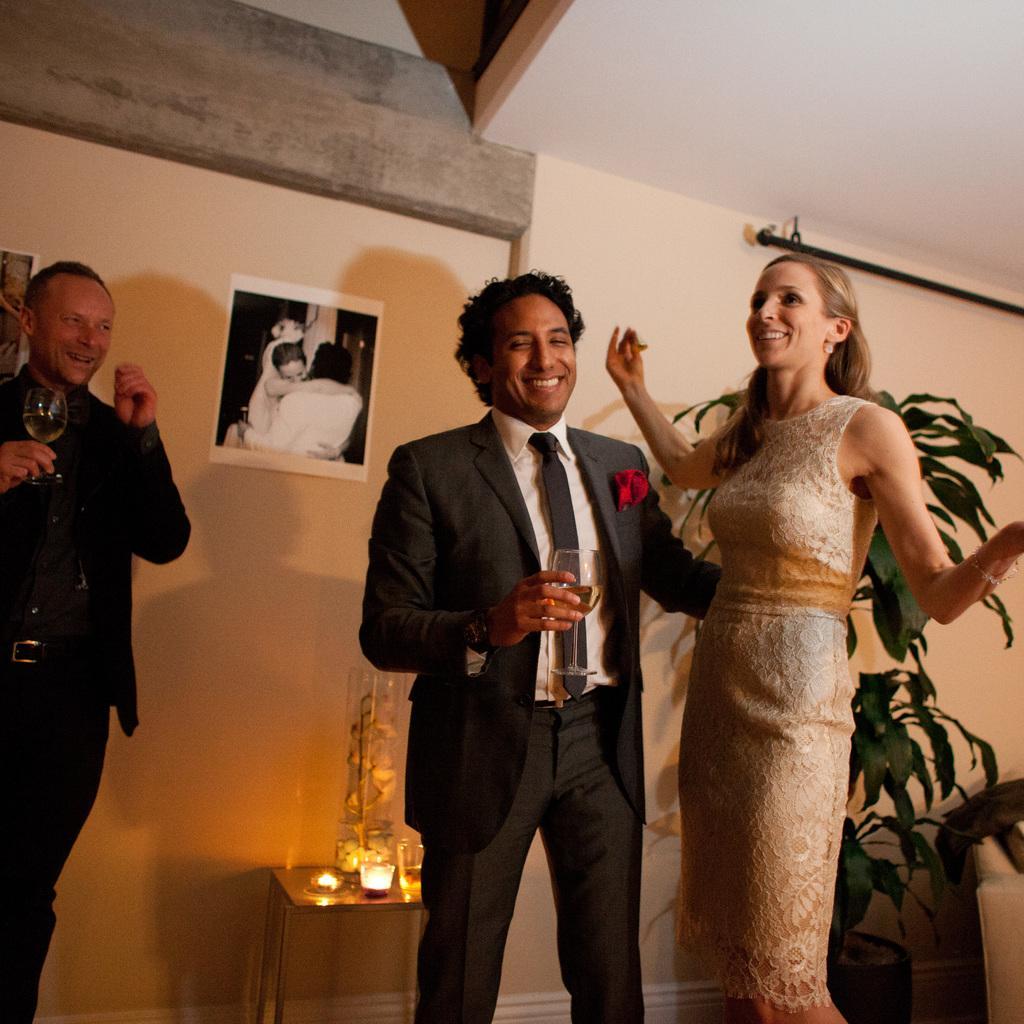How would you summarize this image in a sentence or two? In front of the picture, we see a man and the women are standing. The man is holding a glass containing the liquid in his hand. Both of them are smiling. Behind them, we see a small table on which candle, glass and some other objects are placed. On the left side, we see a man is standing. He is holding a glass containing the liquid and he is smiling. In the background, we see a wall on which the photo frames are placed. On the right side, we see a plant pot and a chair. 